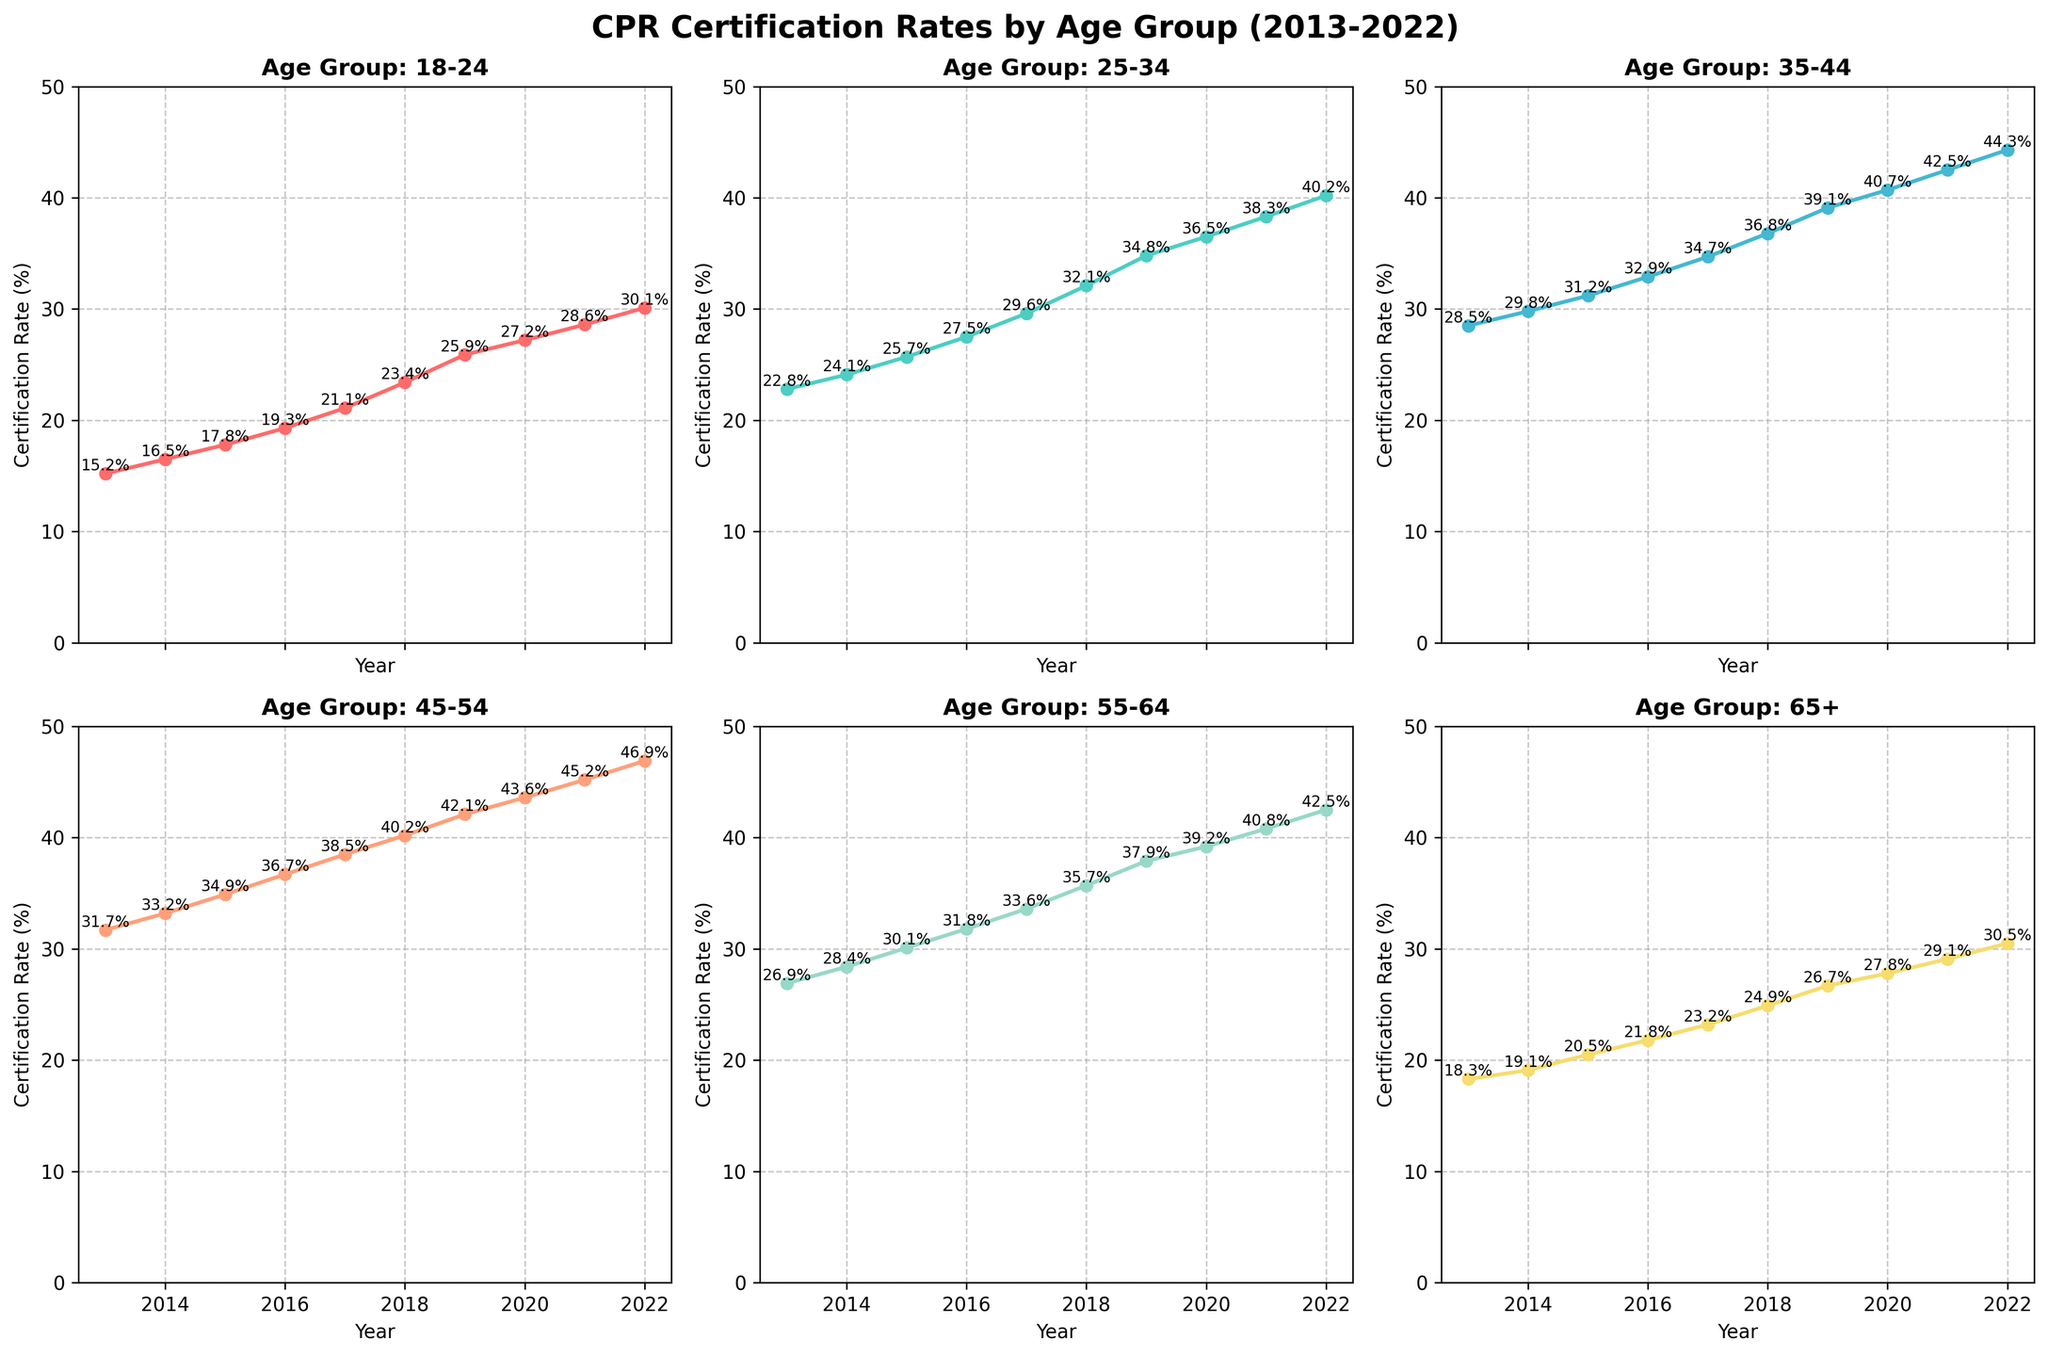What is the title of the figure? The title of the figure is displayed at the top of the chart. By looking at the figure, you can see that the title reads, 'CPR Certification Rates by Age Group (2013-2022)'.
Answer: CPR Certification Rates by Age Group (2013-2022) Which age group had the lowest certification rate in 2013? To find the lowest certification rate in 2013, look at the values for each age group in 2013. The rates are: 15.2, 22.8, 28.5, 31.7, 26.9, and 18.3. The lowest rate is 15.2, which corresponds to the 18-24 age group.
Answer: 18-24 What is the trend in certification rates for the 45-54 age group? To observe the trend, look at how the data points change over the years for the 45-54 age group. The values consistently increase from 31.7 in 2013 to 46.9 in 2022, indicating an upward trend.
Answer: Increasing Which age group saw the highest overall increase in certification rate from 2013 to 2022? Calculate the difference in certification rates between 2013 and 2022 for each age group and find the largest difference. The differences are: 30.1 - 15.2 = 14.9, 40.2 - 22.8 = 17.4, 44.3 - 28.5 = 15.8, 46.9 - 31.7 = 15.2, 42.5 - 26.9 = 15.6, and 30.5 - 18.3 = 12.2. The largest increase is 17.4, which corresponds to the 25-34 age group.
Answer: 25-34 Which age groups' certification rates crossed the 35% mark first and in which year? Examine each line on the chart and identify when the rate first exceeded 35%. The 45-54 age group crossed 35% in 2016, followed by the 35-44 age group in 2018, the 55-64 age group in 2019, the 25-34 age group in 2019, the 18-24 age group in 2020, and the 65+ age group never crossed 35% in the given timeframe. So, the 45-54 age group was first, in 2016.
Answer: 45-54, 2016 In what year did the certification rates for the 25-34 age group surpass 30%? Look at the plot for the 25-34 age group and identify the year when the rate first exceeds 30%. The value surpasses 30% in 2018 when it reaches 32.1%.
Answer: 2018 On average, how much did the certification rates increase per year for the 65+ age group? First, find the difference in certification rates between 2013 and 2022 for the 65+ age group: 30.5 - 18.3 = 12.2. There are 9 intervals between the 10 years from 2013 to 2022, so the average increase per year is 12.2 / 9 = 1.36.
Answer: 1.36 Which age group had the most consistent increase in certification rates over the decade, and what evidence supports this? To determine the consistency, look for a line with steady increments and no significant fluctuations. The 45-54 age group shows a steady, consistent increase each year. This can be observed from the gradual upward slope and lack of sharp changes in the line.
Answer: 45-54 Which age group had the highest certification rate in 2022, and what was that rate? Look at the endpoints of the lines representing certification rates in 2022. The highest value on the rightmost side of the plot corresponds to the 45-54 age group, with a rate of 46.9.
Answer: 45-54, 46.9 